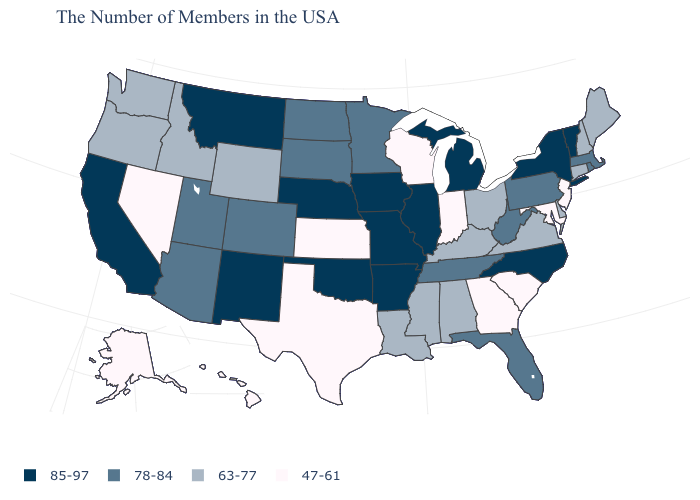What is the lowest value in the West?
Concise answer only. 47-61. What is the value of Connecticut?
Give a very brief answer. 63-77. What is the value of Oklahoma?
Concise answer only. 85-97. What is the value of Wyoming?
Answer briefly. 63-77. What is the value of Mississippi?
Quick response, please. 63-77. What is the value of Iowa?
Answer briefly. 85-97. Which states hav the highest value in the Northeast?
Answer briefly. Vermont, New York. Does the first symbol in the legend represent the smallest category?
Short answer required. No. Name the states that have a value in the range 47-61?
Be succinct. New Jersey, Maryland, South Carolina, Georgia, Indiana, Wisconsin, Kansas, Texas, Nevada, Alaska, Hawaii. Name the states that have a value in the range 47-61?
Keep it brief. New Jersey, Maryland, South Carolina, Georgia, Indiana, Wisconsin, Kansas, Texas, Nevada, Alaska, Hawaii. Which states have the highest value in the USA?
Answer briefly. Vermont, New York, North Carolina, Michigan, Illinois, Missouri, Arkansas, Iowa, Nebraska, Oklahoma, New Mexico, Montana, California. Which states have the lowest value in the USA?
Concise answer only. New Jersey, Maryland, South Carolina, Georgia, Indiana, Wisconsin, Kansas, Texas, Nevada, Alaska, Hawaii. Among the states that border Connecticut , which have the lowest value?
Answer briefly. Massachusetts, Rhode Island. Which states have the lowest value in the South?
Short answer required. Maryland, South Carolina, Georgia, Texas. Name the states that have a value in the range 47-61?
Be succinct. New Jersey, Maryland, South Carolina, Georgia, Indiana, Wisconsin, Kansas, Texas, Nevada, Alaska, Hawaii. 